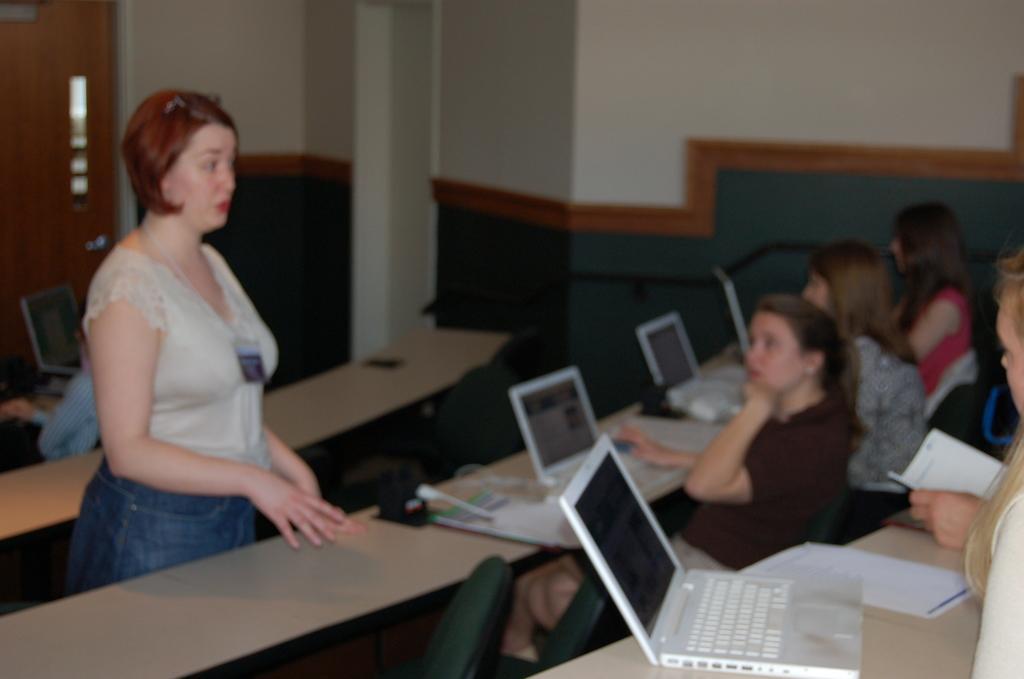In one or two sentences, can you explain what this image depicts? This is blurred picture where a women is standing in front of a desk and on the other side there are people sitting on the chairs in front of a desk where there are laptops and some papers. 